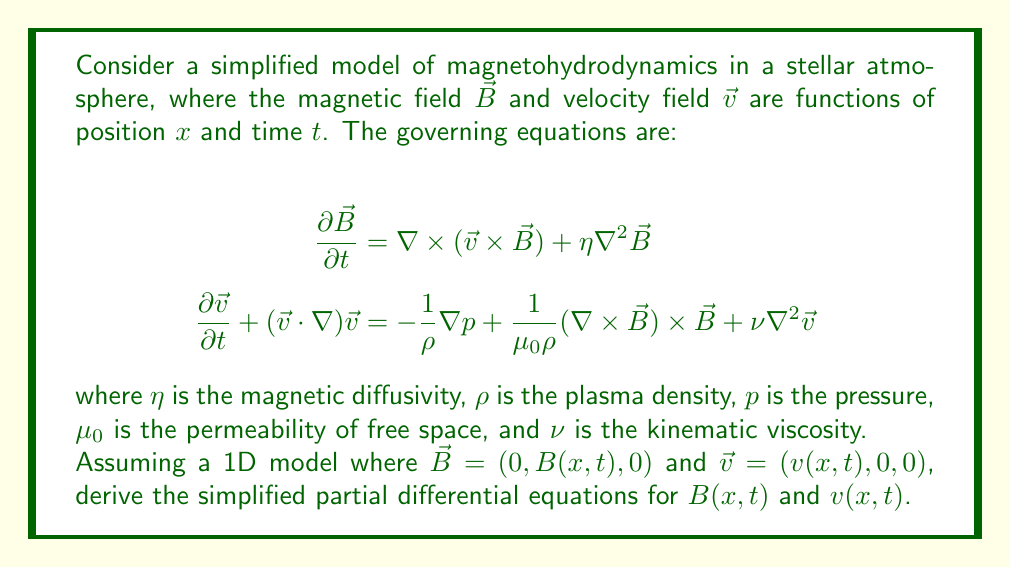Give your solution to this math problem. To simplify the equations, we'll follow these steps:

1) First, let's consider the equation for $\mathbf{B}$:
   $$\frac{\partial \mathbf{B}}{\partial t} = \nabla \times (\mathbf{v} \times \mathbf{B}) + \eta \nabla^2 \mathbf{B}$$

   Given $\mathbf{B} = (0, B(x,t), 0)$ and $\mathbf{v} = (v(x,t), 0, 0)$, we have:
   $\mathbf{v} \times \mathbf{B} = (0, 0, -vB)$

   Therefore, $\nabla \times (\mathbf{v} \times \mathbf{B}) = (0, \frac{\partial}{\partial x}(vB), 0)$

   The Laplacian of $\mathbf{B}$ is $\nabla^2 \mathbf{B} = (0, \frac{\partial^2 B}{\partial x^2}, 0)$

   Combining these, we get:
   $$\frac{\partial B}{\partial t} = \frac{\partial}{\partial x}(vB) + \eta \frac{\partial^2 B}{\partial x^2}$$

2) Now, let's consider the equation for $\mathbf{v}$:
   $$\frac{\partial \mathbf{v}}{\partial t} + (\mathbf{v} \cdot \nabla)\mathbf{v} = -\frac{1}{\rho}\nabla p + \frac{1}{\mu_0 \rho}(\nabla \times \mathbf{B}) \times \mathbf{B} + \nu \nabla^2 \mathbf{v}$$

   The term $(\mathbf{v} \cdot \nabla)\mathbf{v}$ simplifies to $(v\frac{\partial v}{\partial x}, 0, 0)$

   $\nabla \times \mathbf{B} = (0, 0, -\frac{\partial B}{\partial x})$

   Therefore, $(\nabla \times \mathbf{B}) \times \mathbf{B} = (-B\frac{\partial B}{\partial x}, 0, 0)$

   The Laplacian of $\mathbf{v}$ is $\nabla^2 \mathbf{v} = (\frac{\partial^2 v}{\partial x^2}, 0, 0)$

   Combining these and considering only the x-component (as $v$ only has an x-component), we get:
   $$\frac{\partial v}{\partial t} + v\frac{\partial v}{\partial x} = -\frac{1}{\rho}\frac{\partial p}{\partial x} - \frac{1}{\mu_0 \rho}B\frac{\partial B}{\partial x} + \nu \frac{\partial^2 v}{\partial x^2}$$

Thus, we have derived the simplified 1D partial differential equations for $B(x,t)$ and $v(x,t)$.
Answer: $$\frac{\partial B}{\partial t} = \frac{\partial}{\partial x}(vB) + \eta \frac{\partial^2 B}{\partial x^2}$$
$$\frac{\partial v}{\partial t} + v\frac{\partial v}{\partial x} = -\frac{1}{\rho}\frac{\partial p}{\partial x} - \frac{1}{\mu_0 \rho}B\frac{\partial B}{\partial x} + \nu \frac{\partial^2 v}{\partial x^2}$$ 